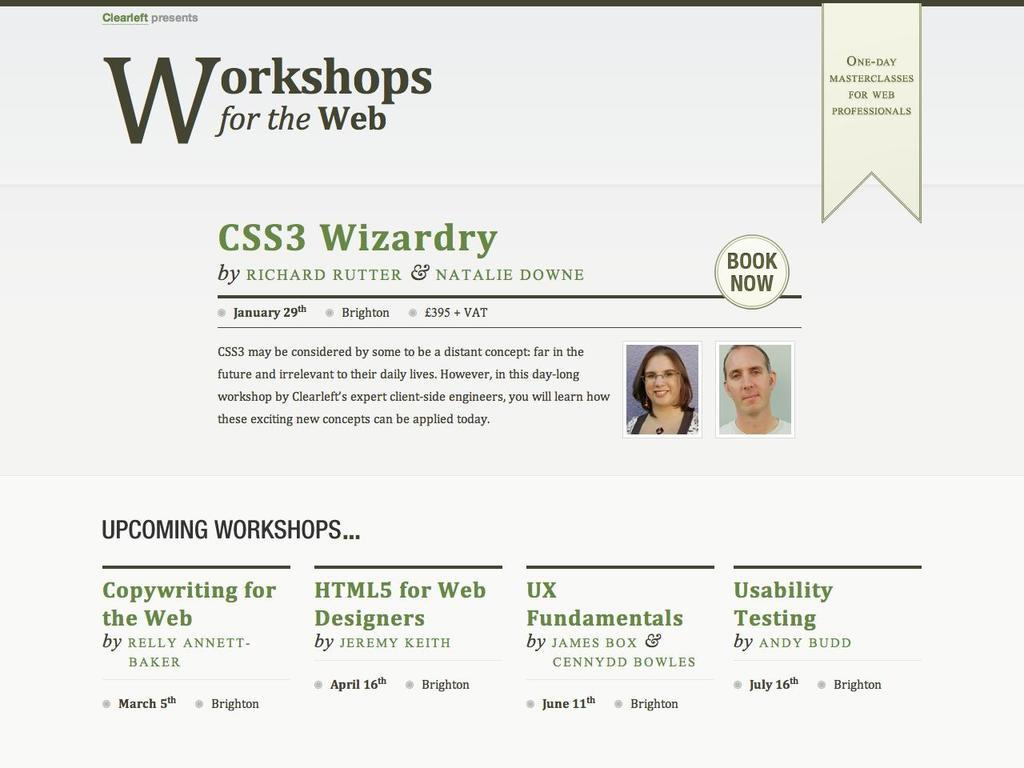What is present in the image that contains both text and images? There is a poster in the image that contains text and images. Can you describe the content of the poster? The poster contains text and images, but the specific content cannot be determined from the provided facts. How many bells are ringing in the image? There are no bells present in the image. What trick is being performed in the image? There is no trick being performed in the image. 